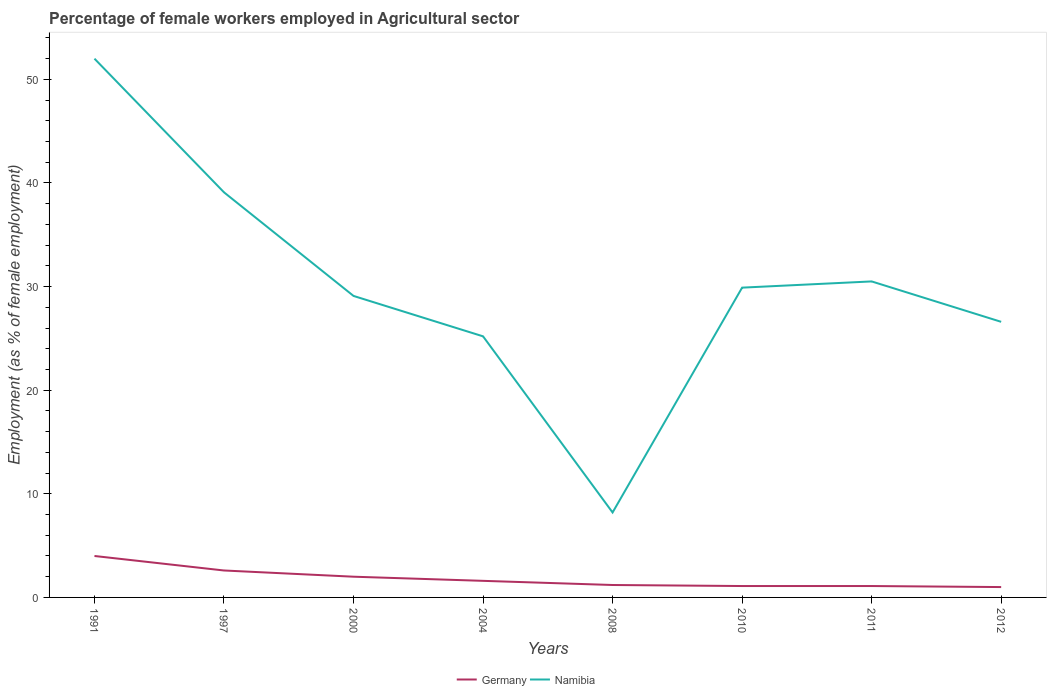How many different coloured lines are there?
Your answer should be compact. 2. Does the line corresponding to Namibia intersect with the line corresponding to Germany?
Your answer should be compact. No. Is the number of lines equal to the number of legend labels?
Offer a very short reply. Yes. In which year was the percentage of females employed in Agricultural sector in Germany maximum?
Ensure brevity in your answer.  2012. What is the total percentage of females employed in Agricultural sector in Namibia in the graph?
Your answer should be compact. -1.4. How many years are there in the graph?
Offer a terse response. 8. Are the values on the major ticks of Y-axis written in scientific E-notation?
Provide a succinct answer. No. Where does the legend appear in the graph?
Provide a succinct answer. Bottom center. What is the title of the graph?
Keep it short and to the point. Percentage of female workers employed in Agricultural sector. Does "Sweden" appear as one of the legend labels in the graph?
Ensure brevity in your answer.  No. What is the label or title of the X-axis?
Ensure brevity in your answer.  Years. What is the label or title of the Y-axis?
Keep it short and to the point. Employment (as % of female employment). What is the Employment (as % of female employment) of Germany in 1991?
Make the answer very short. 4. What is the Employment (as % of female employment) of Namibia in 1991?
Provide a succinct answer. 52. What is the Employment (as % of female employment) in Germany in 1997?
Ensure brevity in your answer.  2.6. What is the Employment (as % of female employment) in Namibia in 1997?
Give a very brief answer. 39.1. What is the Employment (as % of female employment) of Germany in 2000?
Your response must be concise. 2. What is the Employment (as % of female employment) in Namibia in 2000?
Make the answer very short. 29.1. What is the Employment (as % of female employment) in Germany in 2004?
Provide a succinct answer. 1.6. What is the Employment (as % of female employment) of Namibia in 2004?
Offer a very short reply. 25.2. What is the Employment (as % of female employment) of Germany in 2008?
Offer a very short reply. 1.2. What is the Employment (as % of female employment) of Namibia in 2008?
Ensure brevity in your answer.  8.2. What is the Employment (as % of female employment) in Germany in 2010?
Your answer should be very brief. 1.1. What is the Employment (as % of female employment) of Namibia in 2010?
Give a very brief answer. 29.9. What is the Employment (as % of female employment) of Germany in 2011?
Keep it short and to the point. 1.1. What is the Employment (as % of female employment) in Namibia in 2011?
Keep it short and to the point. 30.5. What is the Employment (as % of female employment) in Namibia in 2012?
Give a very brief answer. 26.6. Across all years, what is the maximum Employment (as % of female employment) of Namibia?
Your answer should be very brief. 52. Across all years, what is the minimum Employment (as % of female employment) in Namibia?
Provide a succinct answer. 8.2. What is the total Employment (as % of female employment) of Namibia in the graph?
Ensure brevity in your answer.  240.6. What is the difference between the Employment (as % of female employment) of Germany in 1991 and that in 1997?
Offer a terse response. 1.4. What is the difference between the Employment (as % of female employment) in Germany in 1991 and that in 2000?
Your answer should be compact. 2. What is the difference between the Employment (as % of female employment) of Namibia in 1991 and that in 2000?
Ensure brevity in your answer.  22.9. What is the difference between the Employment (as % of female employment) in Germany in 1991 and that in 2004?
Make the answer very short. 2.4. What is the difference between the Employment (as % of female employment) of Namibia in 1991 and that in 2004?
Your response must be concise. 26.8. What is the difference between the Employment (as % of female employment) of Namibia in 1991 and that in 2008?
Make the answer very short. 43.8. What is the difference between the Employment (as % of female employment) of Germany in 1991 and that in 2010?
Offer a terse response. 2.9. What is the difference between the Employment (as % of female employment) of Namibia in 1991 and that in 2010?
Make the answer very short. 22.1. What is the difference between the Employment (as % of female employment) in Germany in 1991 and that in 2011?
Ensure brevity in your answer.  2.9. What is the difference between the Employment (as % of female employment) of Namibia in 1991 and that in 2011?
Your answer should be compact. 21.5. What is the difference between the Employment (as % of female employment) in Namibia in 1991 and that in 2012?
Provide a succinct answer. 25.4. What is the difference between the Employment (as % of female employment) in Germany in 1997 and that in 2000?
Provide a succinct answer. 0.6. What is the difference between the Employment (as % of female employment) in Namibia in 1997 and that in 2004?
Offer a very short reply. 13.9. What is the difference between the Employment (as % of female employment) in Namibia in 1997 and that in 2008?
Provide a succinct answer. 30.9. What is the difference between the Employment (as % of female employment) in Germany in 1997 and that in 2010?
Your response must be concise. 1.5. What is the difference between the Employment (as % of female employment) of Namibia in 1997 and that in 2011?
Offer a terse response. 8.6. What is the difference between the Employment (as % of female employment) in Germany in 2000 and that in 2004?
Provide a succinct answer. 0.4. What is the difference between the Employment (as % of female employment) of Namibia in 2000 and that in 2008?
Keep it short and to the point. 20.9. What is the difference between the Employment (as % of female employment) of Germany in 2000 and that in 2010?
Your answer should be very brief. 0.9. What is the difference between the Employment (as % of female employment) in Germany in 2000 and that in 2012?
Offer a terse response. 1. What is the difference between the Employment (as % of female employment) of Namibia in 2004 and that in 2008?
Give a very brief answer. 17. What is the difference between the Employment (as % of female employment) of Namibia in 2004 and that in 2010?
Give a very brief answer. -4.7. What is the difference between the Employment (as % of female employment) in Namibia in 2004 and that in 2011?
Your response must be concise. -5.3. What is the difference between the Employment (as % of female employment) in Germany in 2004 and that in 2012?
Provide a short and direct response. 0.6. What is the difference between the Employment (as % of female employment) of Namibia in 2004 and that in 2012?
Ensure brevity in your answer.  -1.4. What is the difference between the Employment (as % of female employment) of Germany in 2008 and that in 2010?
Keep it short and to the point. 0.1. What is the difference between the Employment (as % of female employment) of Namibia in 2008 and that in 2010?
Ensure brevity in your answer.  -21.7. What is the difference between the Employment (as % of female employment) of Namibia in 2008 and that in 2011?
Keep it short and to the point. -22.3. What is the difference between the Employment (as % of female employment) of Namibia in 2008 and that in 2012?
Provide a short and direct response. -18.4. What is the difference between the Employment (as % of female employment) of Namibia in 2010 and that in 2011?
Offer a very short reply. -0.6. What is the difference between the Employment (as % of female employment) of Germany in 2010 and that in 2012?
Ensure brevity in your answer.  0.1. What is the difference between the Employment (as % of female employment) of Namibia in 2010 and that in 2012?
Provide a succinct answer. 3.3. What is the difference between the Employment (as % of female employment) in Germany in 2011 and that in 2012?
Your answer should be compact. 0.1. What is the difference between the Employment (as % of female employment) in Namibia in 2011 and that in 2012?
Ensure brevity in your answer.  3.9. What is the difference between the Employment (as % of female employment) in Germany in 1991 and the Employment (as % of female employment) in Namibia in 1997?
Provide a short and direct response. -35.1. What is the difference between the Employment (as % of female employment) in Germany in 1991 and the Employment (as % of female employment) in Namibia in 2000?
Your response must be concise. -25.1. What is the difference between the Employment (as % of female employment) in Germany in 1991 and the Employment (as % of female employment) in Namibia in 2004?
Your response must be concise. -21.2. What is the difference between the Employment (as % of female employment) in Germany in 1991 and the Employment (as % of female employment) in Namibia in 2010?
Your answer should be compact. -25.9. What is the difference between the Employment (as % of female employment) in Germany in 1991 and the Employment (as % of female employment) in Namibia in 2011?
Your answer should be very brief. -26.5. What is the difference between the Employment (as % of female employment) in Germany in 1991 and the Employment (as % of female employment) in Namibia in 2012?
Keep it short and to the point. -22.6. What is the difference between the Employment (as % of female employment) in Germany in 1997 and the Employment (as % of female employment) in Namibia in 2000?
Make the answer very short. -26.5. What is the difference between the Employment (as % of female employment) in Germany in 1997 and the Employment (as % of female employment) in Namibia in 2004?
Give a very brief answer. -22.6. What is the difference between the Employment (as % of female employment) of Germany in 1997 and the Employment (as % of female employment) of Namibia in 2010?
Your response must be concise. -27.3. What is the difference between the Employment (as % of female employment) of Germany in 1997 and the Employment (as % of female employment) of Namibia in 2011?
Offer a terse response. -27.9. What is the difference between the Employment (as % of female employment) of Germany in 2000 and the Employment (as % of female employment) of Namibia in 2004?
Offer a very short reply. -23.2. What is the difference between the Employment (as % of female employment) in Germany in 2000 and the Employment (as % of female employment) in Namibia in 2008?
Your answer should be very brief. -6.2. What is the difference between the Employment (as % of female employment) in Germany in 2000 and the Employment (as % of female employment) in Namibia in 2010?
Your answer should be very brief. -27.9. What is the difference between the Employment (as % of female employment) of Germany in 2000 and the Employment (as % of female employment) of Namibia in 2011?
Make the answer very short. -28.5. What is the difference between the Employment (as % of female employment) of Germany in 2000 and the Employment (as % of female employment) of Namibia in 2012?
Provide a short and direct response. -24.6. What is the difference between the Employment (as % of female employment) of Germany in 2004 and the Employment (as % of female employment) of Namibia in 2008?
Offer a terse response. -6.6. What is the difference between the Employment (as % of female employment) in Germany in 2004 and the Employment (as % of female employment) in Namibia in 2010?
Ensure brevity in your answer.  -28.3. What is the difference between the Employment (as % of female employment) of Germany in 2004 and the Employment (as % of female employment) of Namibia in 2011?
Your answer should be compact. -28.9. What is the difference between the Employment (as % of female employment) in Germany in 2004 and the Employment (as % of female employment) in Namibia in 2012?
Offer a terse response. -25. What is the difference between the Employment (as % of female employment) of Germany in 2008 and the Employment (as % of female employment) of Namibia in 2010?
Your response must be concise. -28.7. What is the difference between the Employment (as % of female employment) of Germany in 2008 and the Employment (as % of female employment) of Namibia in 2011?
Ensure brevity in your answer.  -29.3. What is the difference between the Employment (as % of female employment) of Germany in 2008 and the Employment (as % of female employment) of Namibia in 2012?
Your answer should be compact. -25.4. What is the difference between the Employment (as % of female employment) in Germany in 2010 and the Employment (as % of female employment) in Namibia in 2011?
Your response must be concise. -29.4. What is the difference between the Employment (as % of female employment) of Germany in 2010 and the Employment (as % of female employment) of Namibia in 2012?
Provide a short and direct response. -25.5. What is the difference between the Employment (as % of female employment) of Germany in 2011 and the Employment (as % of female employment) of Namibia in 2012?
Keep it short and to the point. -25.5. What is the average Employment (as % of female employment) of Germany per year?
Offer a very short reply. 1.82. What is the average Employment (as % of female employment) of Namibia per year?
Keep it short and to the point. 30.07. In the year 1991, what is the difference between the Employment (as % of female employment) of Germany and Employment (as % of female employment) of Namibia?
Provide a short and direct response. -48. In the year 1997, what is the difference between the Employment (as % of female employment) in Germany and Employment (as % of female employment) in Namibia?
Ensure brevity in your answer.  -36.5. In the year 2000, what is the difference between the Employment (as % of female employment) of Germany and Employment (as % of female employment) of Namibia?
Your answer should be very brief. -27.1. In the year 2004, what is the difference between the Employment (as % of female employment) of Germany and Employment (as % of female employment) of Namibia?
Your response must be concise. -23.6. In the year 2008, what is the difference between the Employment (as % of female employment) of Germany and Employment (as % of female employment) of Namibia?
Provide a short and direct response. -7. In the year 2010, what is the difference between the Employment (as % of female employment) of Germany and Employment (as % of female employment) of Namibia?
Give a very brief answer. -28.8. In the year 2011, what is the difference between the Employment (as % of female employment) of Germany and Employment (as % of female employment) of Namibia?
Your answer should be very brief. -29.4. In the year 2012, what is the difference between the Employment (as % of female employment) in Germany and Employment (as % of female employment) in Namibia?
Provide a short and direct response. -25.6. What is the ratio of the Employment (as % of female employment) in Germany in 1991 to that in 1997?
Make the answer very short. 1.54. What is the ratio of the Employment (as % of female employment) in Namibia in 1991 to that in 1997?
Keep it short and to the point. 1.33. What is the ratio of the Employment (as % of female employment) in Germany in 1991 to that in 2000?
Provide a short and direct response. 2. What is the ratio of the Employment (as % of female employment) in Namibia in 1991 to that in 2000?
Offer a very short reply. 1.79. What is the ratio of the Employment (as % of female employment) of Germany in 1991 to that in 2004?
Offer a terse response. 2.5. What is the ratio of the Employment (as % of female employment) of Namibia in 1991 to that in 2004?
Ensure brevity in your answer.  2.06. What is the ratio of the Employment (as % of female employment) of Namibia in 1991 to that in 2008?
Make the answer very short. 6.34. What is the ratio of the Employment (as % of female employment) of Germany in 1991 to that in 2010?
Your response must be concise. 3.64. What is the ratio of the Employment (as % of female employment) in Namibia in 1991 to that in 2010?
Ensure brevity in your answer.  1.74. What is the ratio of the Employment (as % of female employment) of Germany in 1991 to that in 2011?
Provide a short and direct response. 3.64. What is the ratio of the Employment (as % of female employment) of Namibia in 1991 to that in 2011?
Your response must be concise. 1.7. What is the ratio of the Employment (as % of female employment) in Namibia in 1991 to that in 2012?
Keep it short and to the point. 1.95. What is the ratio of the Employment (as % of female employment) in Germany in 1997 to that in 2000?
Ensure brevity in your answer.  1.3. What is the ratio of the Employment (as % of female employment) of Namibia in 1997 to that in 2000?
Ensure brevity in your answer.  1.34. What is the ratio of the Employment (as % of female employment) of Germany in 1997 to that in 2004?
Offer a terse response. 1.62. What is the ratio of the Employment (as % of female employment) of Namibia in 1997 to that in 2004?
Your answer should be compact. 1.55. What is the ratio of the Employment (as % of female employment) in Germany in 1997 to that in 2008?
Offer a very short reply. 2.17. What is the ratio of the Employment (as % of female employment) of Namibia in 1997 to that in 2008?
Provide a short and direct response. 4.77. What is the ratio of the Employment (as % of female employment) of Germany in 1997 to that in 2010?
Your response must be concise. 2.36. What is the ratio of the Employment (as % of female employment) of Namibia in 1997 to that in 2010?
Your answer should be compact. 1.31. What is the ratio of the Employment (as % of female employment) in Germany in 1997 to that in 2011?
Offer a very short reply. 2.36. What is the ratio of the Employment (as % of female employment) in Namibia in 1997 to that in 2011?
Make the answer very short. 1.28. What is the ratio of the Employment (as % of female employment) of Namibia in 1997 to that in 2012?
Your answer should be compact. 1.47. What is the ratio of the Employment (as % of female employment) of Namibia in 2000 to that in 2004?
Ensure brevity in your answer.  1.15. What is the ratio of the Employment (as % of female employment) of Germany in 2000 to that in 2008?
Make the answer very short. 1.67. What is the ratio of the Employment (as % of female employment) in Namibia in 2000 to that in 2008?
Keep it short and to the point. 3.55. What is the ratio of the Employment (as % of female employment) in Germany in 2000 to that in 2010?
Make the answer very short. 1.82. What is the ratio of the Employment (as % of female employment) in Namibia in 2000 to that in 2010?
Your answer should be compact. 0.97. What is the ratio of the Employment (as % of female employment) in Germany in 2000 to that in 2011?
Keep it short and to the point. 1.82. What is the ratio of the Employment (as % of female employment) of Namibia in 2000 to that in 2011?
Keep it short and to the point. 0.95. What is the ratio of the Employment (as % of female employment) in Namibia in 2000 to that in 2012?
Your answer should be very brief. 1.09. What is the ratio of the Employment (as % of female employment) in Namibia in 2004 to that in 2008?
Offer a terse response. 3.07. What is the ratio of the Employment (as % of female employment) of Germany in 2004 to that in 2010?
Offer a very short reply. 1.45. What is the ratio of the Employment (as % of female employment) of Namibia in 2004 to that in 2010?
Provide a succinct answer. 0.84. What is the ratio of the Employment (as % of female employment) in Germany in 2004 to that in 2011?
Provide a short and direct response. 1.45. What is the ratio of the Employment (as % of female employment) of Namibia in 2004 to that in 2011?
Make the answer very short. 0.83. What is the ratio of the Employment (as % of female employment) in Germany in 2004 to that in 2012?
Offer a very short reply. 1.6. What is the ratio of the Employment (as % of female employment) in Germany in 2008 to that in 2010?
Make the answer very short. 1.09. What is the ratio of the Employment (as % of female employment) in Namibia in 2008 to that in 2010?
Offer a very short reply. 0.27. What is the ratio of the Employment (as % of female employment) in Germany in 2008 to that in 2011?
Provide a short and direct response. 1.09. What is the ratio of the Employment (as % of female employment) in Namibia in 2008 to that in 2011?
Ensure brevity in your answer.  0.27. What is the ratio of the Employment (as % of female employment) of Namibia in 2008 to that in 2012?
Ensure brevity in your answer.  0.31. What is the ratio of the Employment (as % of female employment) in Germany in 2010 to that in 2011?
Make the answer very short. 1. What is the ratio of the Employment (as % of female employment) of Namibia in 2010 to that in 2011?
Provide a short and direct response. 0.98. What is the ratio of the Employment (as % of female employment) of Germany in 2010 to that in 2012?
Keep it short and to the point. 1.1. What is the ratio of the Employment (as % of female employment) of Namibia in 2010 to that in 2012?
Your response must be concise. 1.12. What is the ratio of the Employment (as % of female employment) in Namibia in 2011 to that in 2012?
Your answer should be very brief. 1.15. What is the difference between the highest and the second highest Employment (as % of female employment) of Germany?
Provide a succinct answer. 1.4. What is the difference between the highest and the lowest Employment (as % of female employment) in Namibia?
Keep it short and to the point. 43.8. 